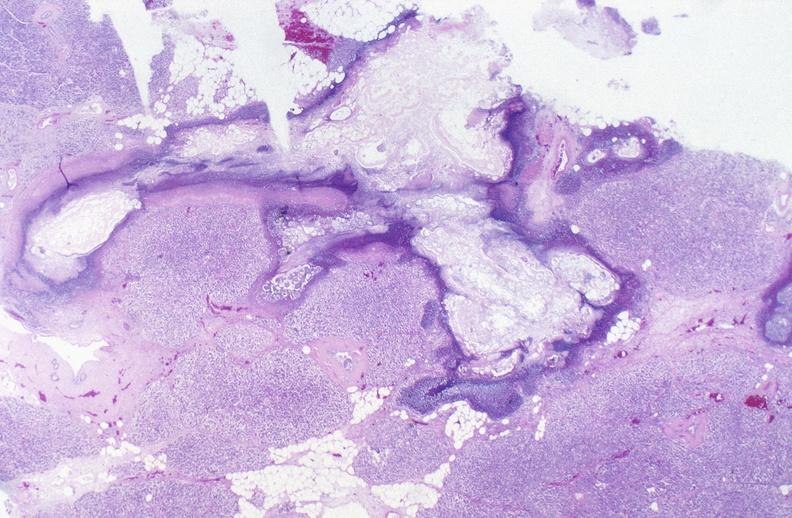does anomalous origin show pancreatic fat necrosis?
Answer the question using a single word or phrase. No 